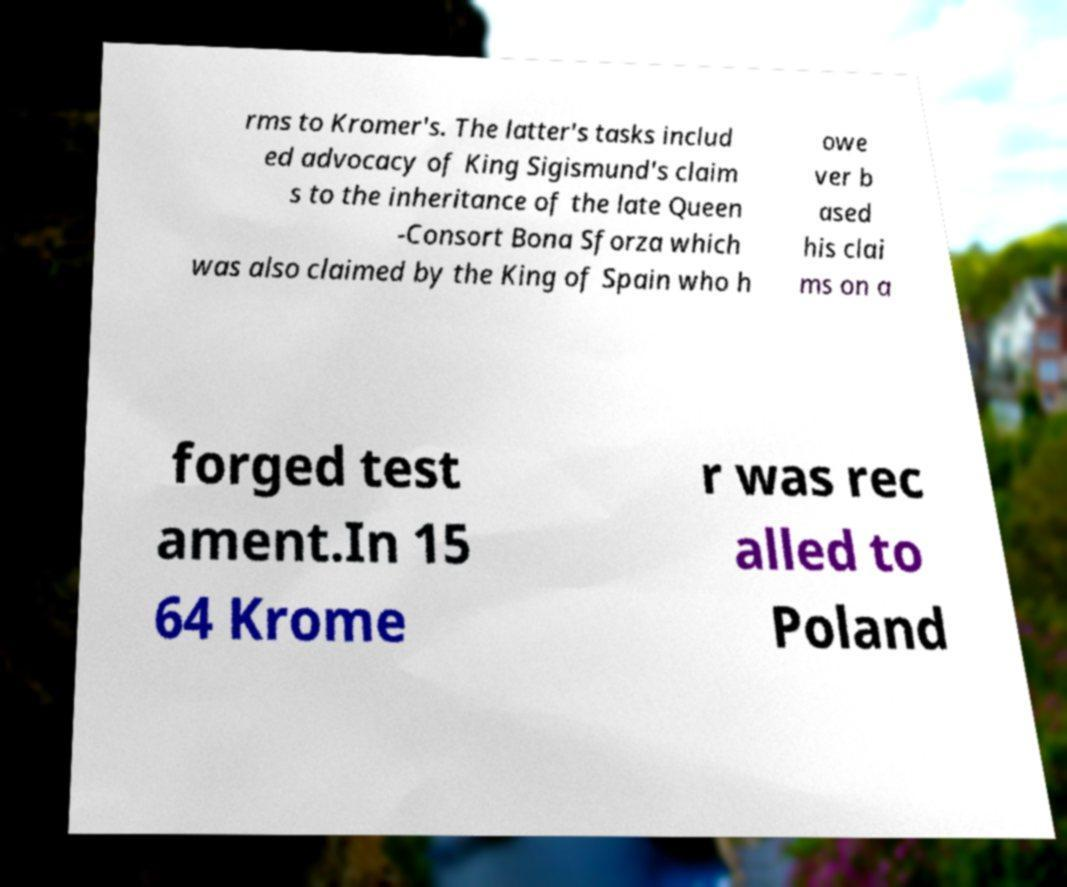What messages or text are displayed in this image? I need them in a readable, typed format. rms to Kromer's. The latter's tasks includ ed advocacy of King Sigismund's claim s to the inheritance of the late Queen -Consort Bona Sforza which was also claimed by the King of Spain who h owe ver b ased his clai ms on a forged test ament.In 15 64 Krome r was rec alled to Poland 